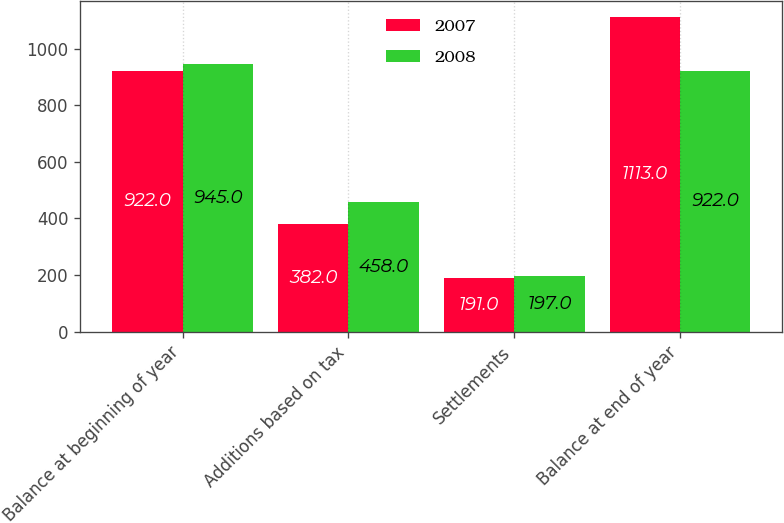<chart> <loc_0><loc_0><loc_500><loc_500><stacked_bar_chart><ecel><fcel>Balance at beginning of year<fcel>Additions based on tax<fcel>Settlements<fcel>Balance at end of year<nl><fcel>2007<fcel>922<fcel>382<fcel>191<fcel>1113<nl><fcel>2008<fcel>945<fcel>458<fcel>197<fcel>922<nl></chart> 